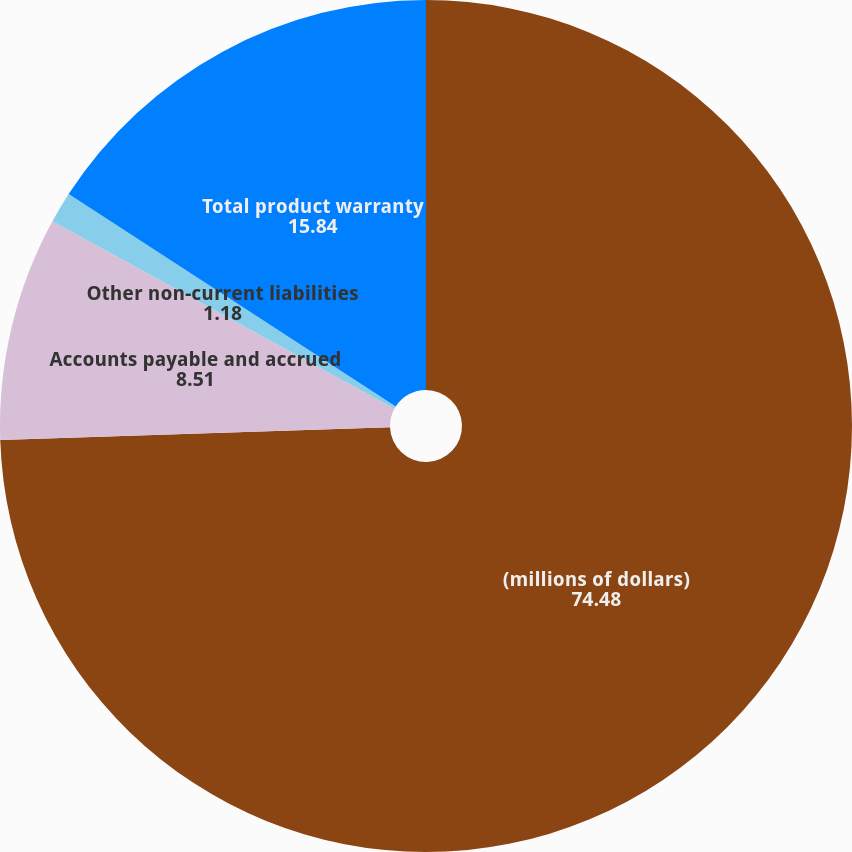Convert chart. <chart><loc_0><loc_0><loc_500><loc_500><pie_chart><fcel>(millions of dollars)<fcel>Accounts payable and accrued<fcel>Other non-current liabilities<fcel>Total product warranty<nl><fcel>74.48%<fcel>8.51%<fcel>1.18%<fcel>15.84%<nl></chart> 